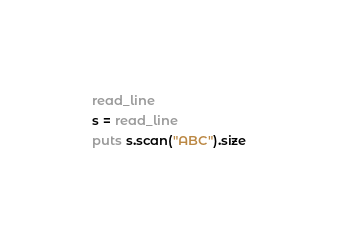<code> <loc_0><loc_0><loc_500><loc_500><_Crystal_>read_line
s = read_line
puts s.scan("ABC").size
</code> 